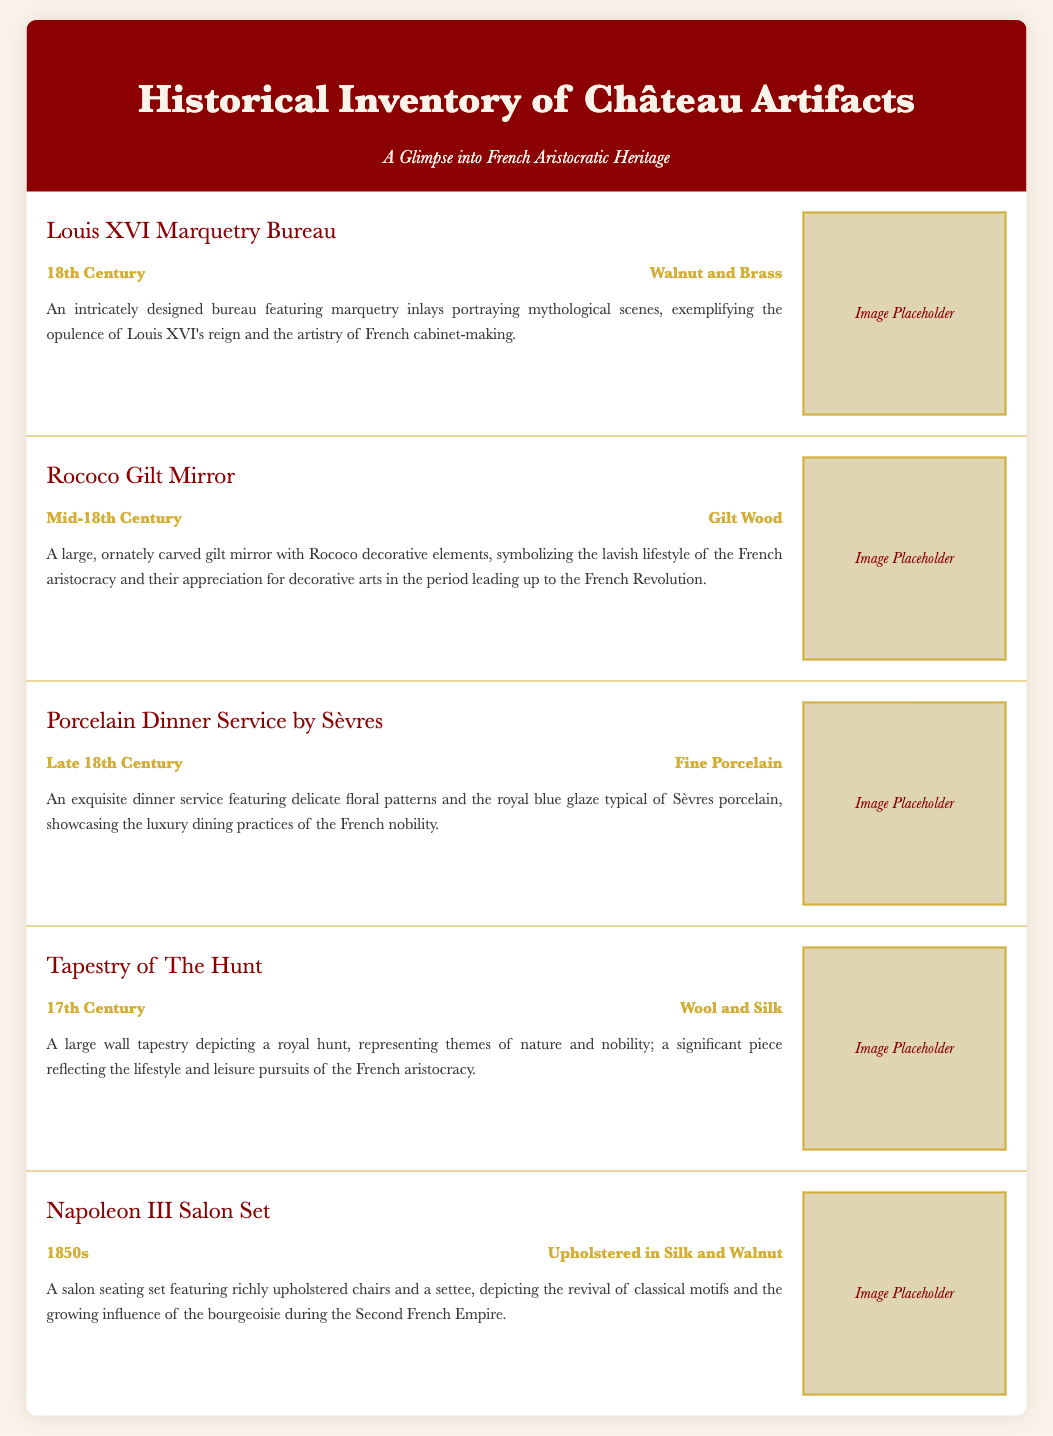What is the period of the Louis XVI Marquetry Bureau? The period of the Louis XVI Marquetry Bureau is stated in the document as "18th Century."
Answer: 18th Century What material is used for the Rococo Gilt Mirror? The document specifies that the material used for the Rococo Gilt Mirror is "Gilt Wood."
Answer: Gilt Wood What is depicted in the Tapestry of The Hunt? The document describes the Tapestry of The Hunt as depicting "a royal hunt."
Answer: a royal hunt What period do the artifacts listed in this document primarily belong to? By reviewing the periods mentioned for each artifact, the periods range from the 17th to the 19th centuries, often celebrating the aristocratic heritage of France.
Answer: 17th to 19th centuries How many artifacts are described in the document? The document outlines a total of five artifacts in its inventory.
Answer: Five What type of service is the Porcelain Dinner Service by Sèvres? The document lists it as a "dinner service."
Answer: dinner service Which artifact features mythological scenes? According to the document, the "Louis XVI Marquetry Bureau" features mythological scenes.
Answer: Louis XVI Marquetry Bureau What style is the Napoleon III Salon Set upholstery? The document indicates that the Napoleon III Salon Set is "upholstered in Silk."
Answer: Silk 